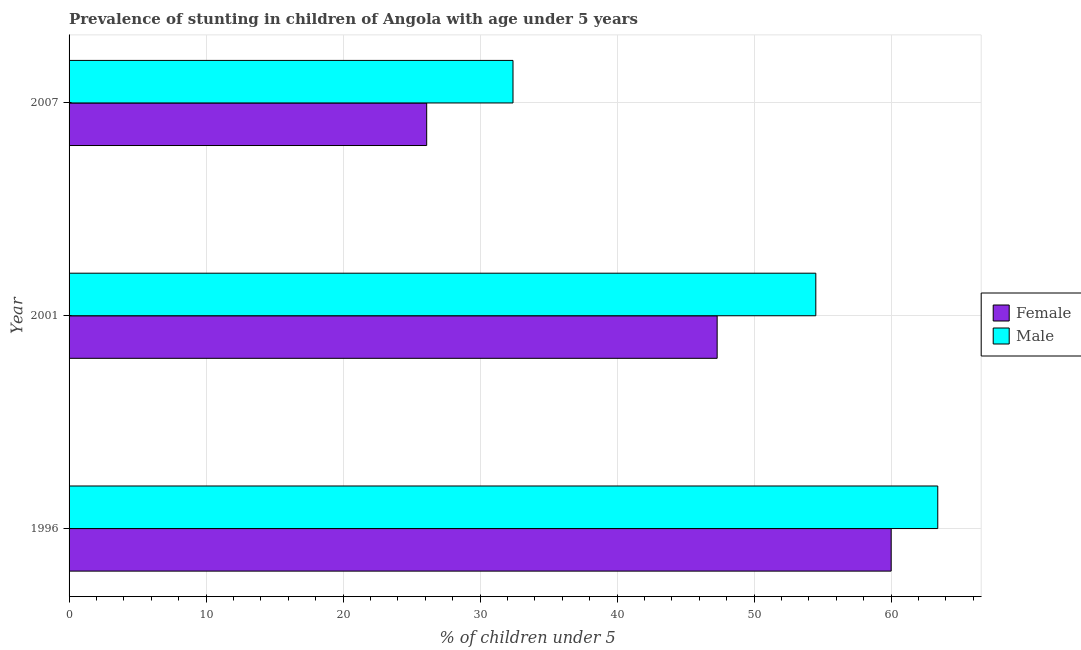How many different coloured bars are there?
Keep it short and to the point. 2. Are the number of bars per tick equal to the number of legend labels?
Make the answer very short. Yes. How many bars are there on the 1st tick from the bottom?
Your answer should be compact. 2. What is the percentage of stunted male children in 2001?
Your response must be concise. 54.5. Across all years, what is the maximum percentage of stunted male children?
Offer a very short reply. 63.4. Across all years, what is the minimum percentage of stunted female children?
Ensure brevity in your answer.  26.1. In which year was the percentage of stunted male children minimum?
Give a very brief answer. 2007. What is the total percentage of stunted male children in the graph?
Ensure brevity in your answer.  150.3. What is the difference between the percentage of stunted male children in 1996 and that in 2007?
Your answer should be compact. 31. What is the difference between the percentage of stunted male children in 2001 and the percentage of stunted female children in 2007?
Ensure brevity in your answer.  28.4. What is the average percentage of stunted female children per year?
Give a very brief answer. 44.47. What is the ratio of the percentage of stunted female children in 1996 to that in 2007?
Provide a succinct answer. 2.3. Is the percentage of stunted male children in 1996 less than that in 2007?
Give a very brief answer. No. What is the difference between the highest and the lowest percentage of stunted male children?
Offer a terse response. 31. What does the 1st bar from the top in 2001 represents?
Your response must be concise. Male. What does the 2nd bar from the bottom in 2007 represents?
Provide a short and direct response. Male. How many bars are there?
Your answer should be compact. 6. Are all the bars in the graph horizontal?
Give a very brief answer. Yes. How many years are there in the graph?
Keep it short and to the point. 3. What is the difference between two consecutive major ticks on the X-axis?
Keep it short and to the point. 10. Does the graph contain any zero values?
Offer a very short reply. No. Where does the legend appear in the graph?
Offer a terse response. Center right. How are the legend labels stacked?
Give a very brief answer. Vertical. What is the title of the graph?
Your answer should be very brief. Prevalence of stunting in children of Angola with age under 5 years. Does "Taxes on exports" appear as one of the legend labels in the graph?
Give a very brief answer. No. What is the label or title of the X-axis?
Provide a succinct answer.  % of children under 5. What is the  % of children under 5 of Male in 1996?
Ensure brevity in your answer.  63.4. What is the  % of children under 5 of Female in 2001?
Your answer should be very brief. 47.3. What is the  % of children under 5 of Male in 2001?
Give a very brief answer. 54.5. What is the  % of children under 5 in Female in 2007?
Provide a short and direct response. 26.1. What is the  % of children under 5 of Male in 2007?
Provide a succinct answer. 32.4. Across all years, what is the maximum  % of children under 5 of Female?
Ensure brevity in your answer.  60. Across all years, what is the maximum  % of children under 5 in Male?
Make the answer very short. 63.4. Across all years, what is the minimum  % of children under 5 in Female?
Your response must be concise. 26.1. Across all years, what is the minimum  % of children under 5 of Male?
Your answer should be compact. 32.4. What is the total  % of children under 5 in Female in the graph?
Offer a terse response. 133.4. What is the total  % of children under 5 in Male in the graph?
Provide a short and direct response. 150.3. What is the difference between the  % of children under 5 in Female in 1996 and that in 2007?
Your response must be concise. 33.9. What is the difference between the  % of children under 5 of Male in 1996 and that in 2007?
Offer a terse response. 31. What is the difference between the  % of children under 5 of Female in 2001 and that in 2007?
Make the answer very short. 21.2. What is the difference between the  % of children under 5 of Male in 2001 and that in 2007?
Provide a short and direct response. 22.1. What is the difference between the  % of children under 5 of Female in 1996 and the  % of children under 5 of Male in 2007?
Your answer should be compact. 27.6. What is the difference between the  % of children under 5 in Female in 2001 and the  % of children under 5 in Male in 2007?
Provide a short and direct response. 14.9. What is the average  % of children under 5 of Female per year?
Keep it short and to the point. 44.47. What is the average  % of children under 5 of Male per year?
Your answer should be compact. 50.1. In the year 1996, what is the difference between the  % of children under 5 in Female and  % of children under 5 in Male?
Keep it short and to the point. -3.4. In the year 2001, what is the difference between the  % of children under 5 in Female and  % of children under 5 in Male?
Your answer should be very brief. -7.2. What is the ratio of the  % of children under 5 of Female in 1996 to that in 2001?
Provide a succinct answer. 1.27. What is the ratio of the  % of children under 5 in Male in 1996 to that in 2001?
Your answer should be compact. 1.16. What is the ratio of the  % of children under 5 in Female in 1996 to that in 2007?
Your answer should be compact. 2.3. What is the ratio of the  % of children under 5 in Male in 1996 to that in 2007?
Offer a very short reply. 1.96. What is the ratio of the  % of children under 5 in Female in 2001 to that in 2007?
Your answer should be compact. 1.81. What is the ratio of the  % of children under 5 in Male in 2001 to that in 2007?
Your answer should be compact. 1.68. What is the difference between the highest and the second highest  % of children under 5 in Female?
Your answer should be very brief. 12.7. What is the difference between the highest and the lowest  % of children under 5 of Female?
Ensure brevity in your answer.  33.9. What is the difference between the highest and the lowest  % of children under 5 in Male?
Keep it short and to the point. 31. 